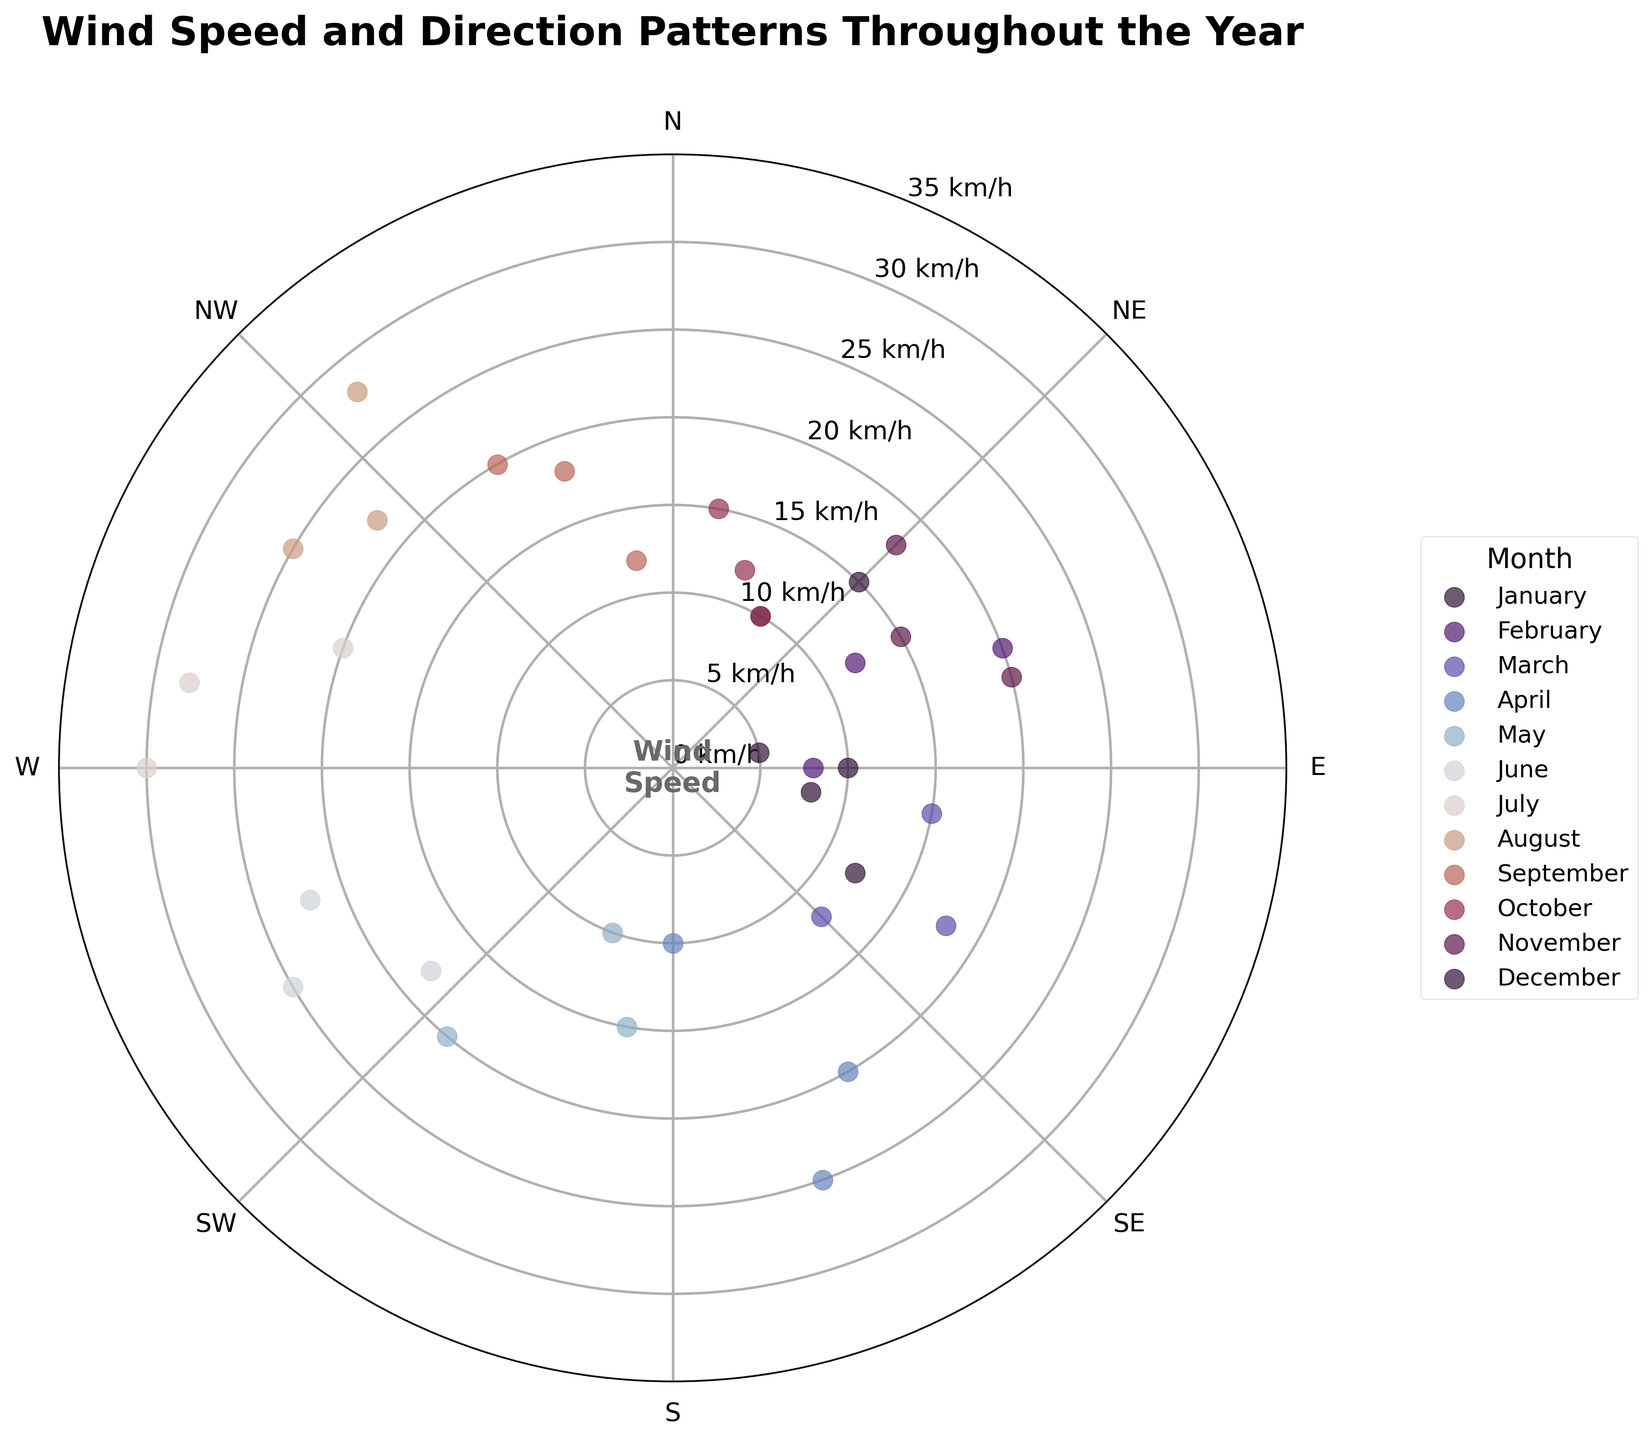What is the title of the figure? The title is usually placed at the top of the figure and reads, "Wind Speed and Direction Patterns Throughout the Year."
Answer: Wind Speed and Direction Patterns Throughout the Year How are the wind directions represented in the chart? Wind directions are represented in degrees and mapped onto a polar coordinate system, with directions like N (0°), NE (45°), and E (90°) shown around the circle.
Answer: Degrees on a polar coordinate system Which month has the highest recorded wind speed and what is the value? The highest wind speeds are generally shown by the largest radial distance from the center. By checking the plot carefully, we can see that July has the highest wind speed at around 30 km/h.
Answer: July, 30 km/h What is the general pattern of wind direction across all months? One would observe the scatter points around the entire circle of directions. This would show that wind directions vary widely throughout the year with no single direction dominating across all months.
Answer: Varies widely throughout the year How does the wind speed in April compare to that in December? By looking at the points for April and December, you can observe that April has higher wind speeds, with points further from the center compared to December's points which are closer to the center.
Answer: April has higher wind speeds than December Which months have wind directions predominantly between 270° and 360°? Observing the scatter points in the fourth quadrant of the polar chart (270°-360°), we can see that these wind directions mainly occur in the months of July, August, and September.
Answer: July, August, September What's the average wind speed recorded in March? To find this, identify and average out the radial distances for March's points. March has 3 points with speeds: 15, 18, and 12 km/h. Summing them gives 45, and dividing by 3 gives an average wind speed of 15 km/h.
Answer: 15 km/h Which two months have the closest wind speed data points? By examining the plot points visually, we can observe that October and December have wind speed data points that are clustered closely together with lower wind speeds, implying very similar wind speed patterns.
Answer: October and December Is there any month that shows a clear predominance of wind coming from the same direction? Looking at the scatter plots, no single month stands out with wind data points all clustered in one direction. It indicates that wind directions are quite varied within each month.
Answer: No month shows a clear predominance 